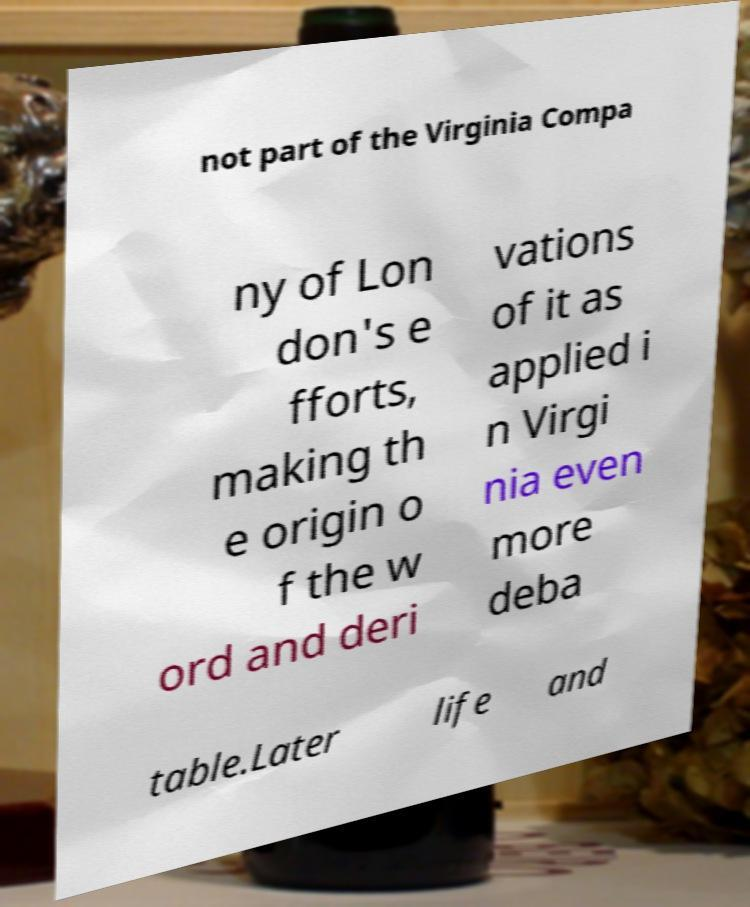For documentation purposes, I need the text within this image transcribed. Could you provide that? not part of the Virginia Compa ny of Lon don's e fforts, making th e origin o f the w ord and deri vations of it as applied i n Virgi nia even more deba table.Later life and 